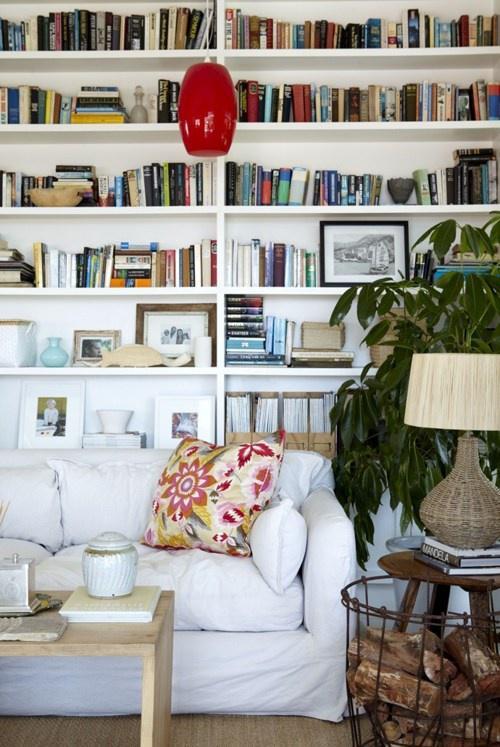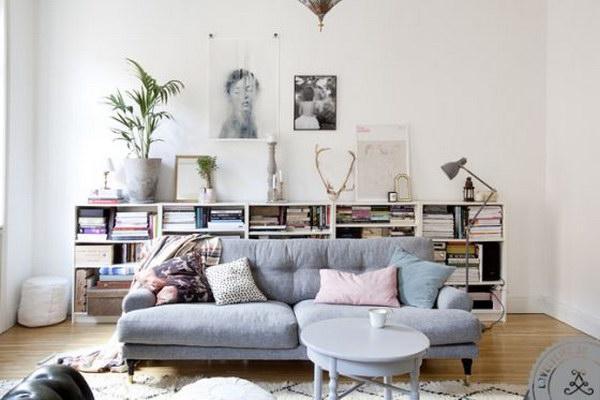The first image is the image on the left, the second image is the image on the right. Analyze the images presented: Is the assertion "An image features a round white table in front of a horizontal couch with assorted pillows, which is in front of a white bookcase." valid? Answer yes or no. Yes. The first image is the image on the left, the second image is the image on the right. Examine the images to the left and right. Is the description "One of the tables is small, white, and round." accurate? Answer yes or no. Yes. 